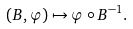<formula> <loc_0><loc_0><loc_500><loc_500>( B , \varphi ) \mapsto \varphi \circ B ^ { - 1 } .</formula> 